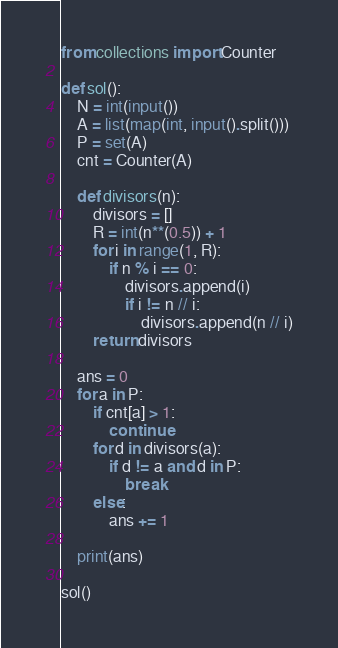Convert code to text. <code><loc_0><loc_0><loc_500><loc_500><_Python_>from collections import Counter

def sol():
    N = int(input())
    A = list(map(int, input().split()))
    P = set(A)
    cnt = Counter(A)

    def divisors(n):
        divisors = []
        R = int(n**(0.5)) + 1
        for i in range(1, R):
            if n % i == 0:
                divisors.append(i)
                if i != n // i:
                    divisors.append(n // i)
        return divisors

    ans = 0
    for a in P:
        if cnt[a] > 1:
            continue
        for d in divisors(a):
            if d != a and d in P:
                break
        else:
            ans += 1

    print(ans)

sol()</code> 